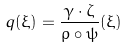<formula> <loc_0><loc_0><loc_500><loc_500>q ( \xi ) = \frac { \gamma \cdot \zeta } { \rho \circ \psi } ( \xi )</formula> 